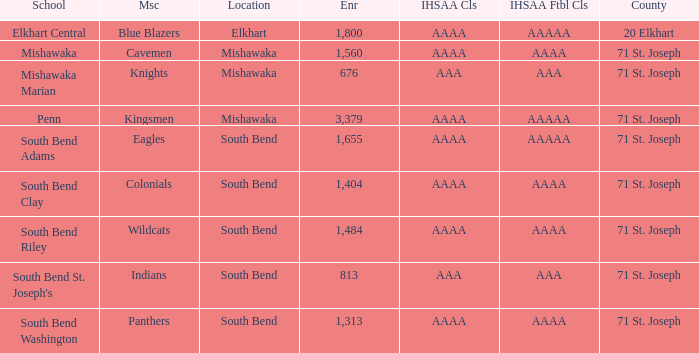What location has an enrollment greater than 1,313, and kingsmen as the mascot? Mishawaka. 